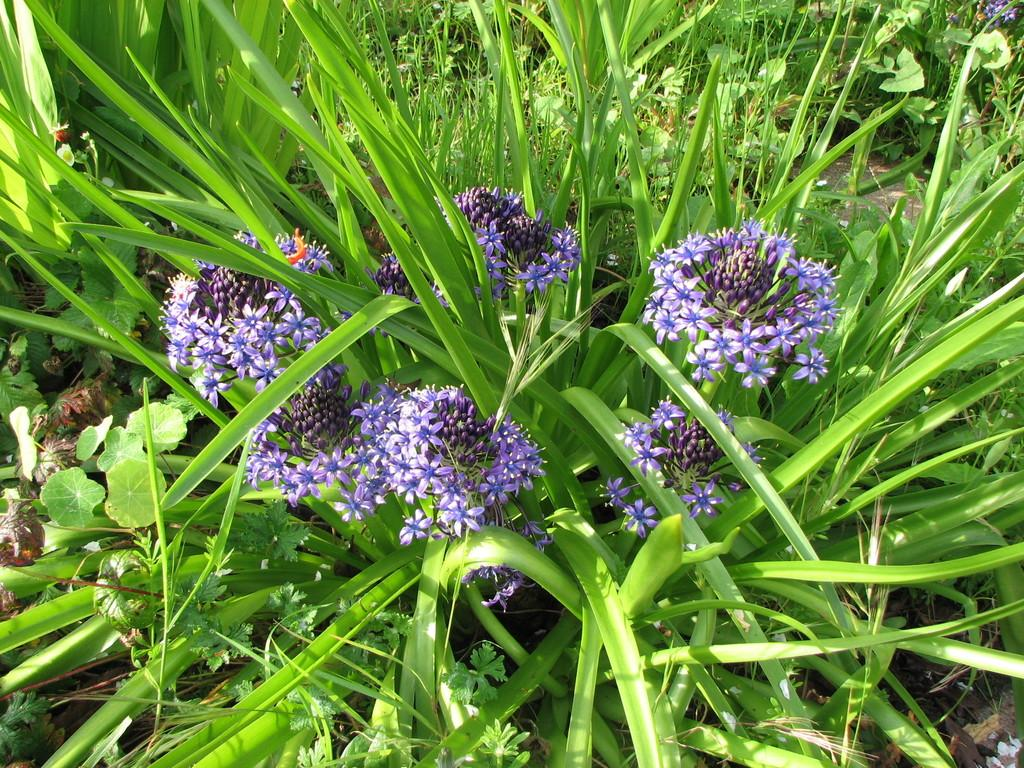What type of living organisms can be seen in the image? Plants can be seen in the image. What color are the flowers on the plants? The flowers on the plants are purple. Can you hear the plants in the image? No, plants do not produce sounds that can be heard, so it is not possible to hear them in the image. 